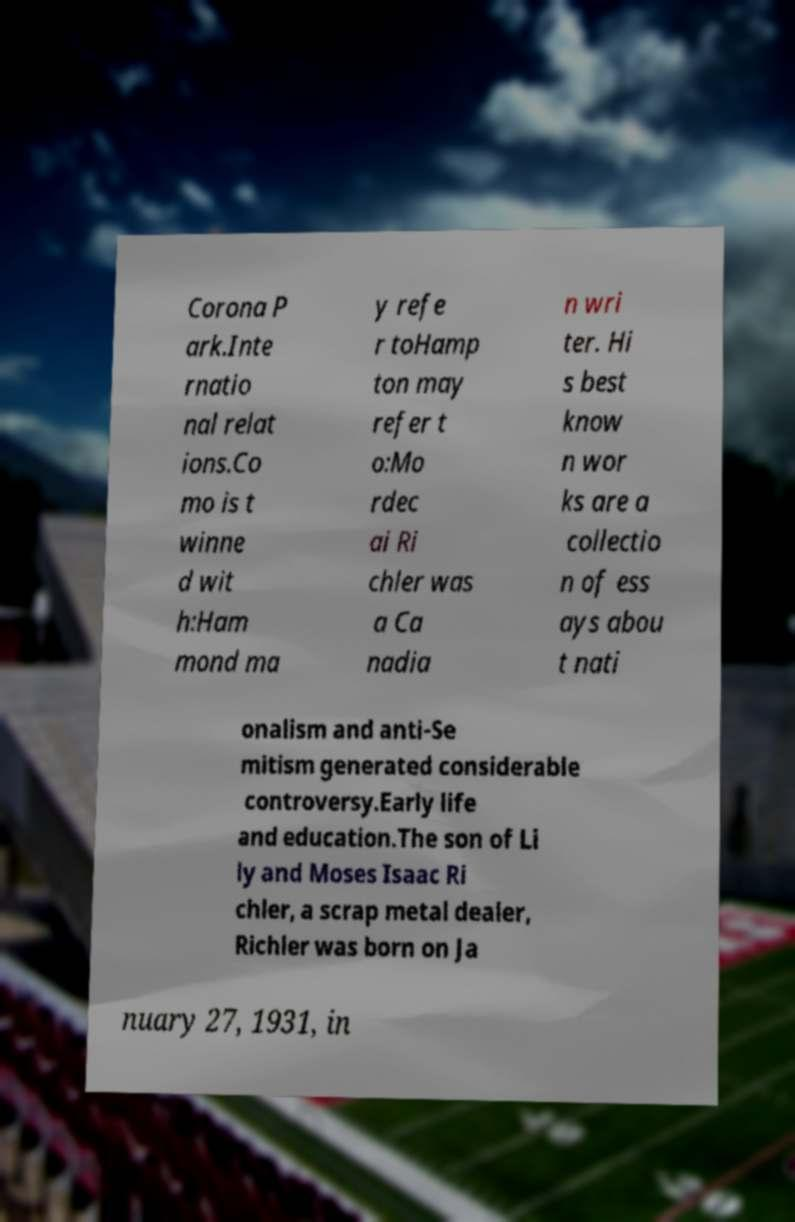Can you read and provide the text displayed in the image?This photo seems to have some interesting text. Can you extract and type it out for me? Corona P ark.Inte rnatio nal relat ions.Co mo is t winne d wit h:Ham mond ma y refe r toHamp ton may refer t o:Mo rdec ai Ri chler was a Ca nadia n wri ter. Hi s best know n wor ks are a collectio n of ess ays abou t nati onalism and anti-Se mitism generated considerable controversy.Early life and education.The son of Li ly and Moses Isaac Ri chler, a scrap metal dealer, Richler was born on Ja nuary 27, 1931, in 